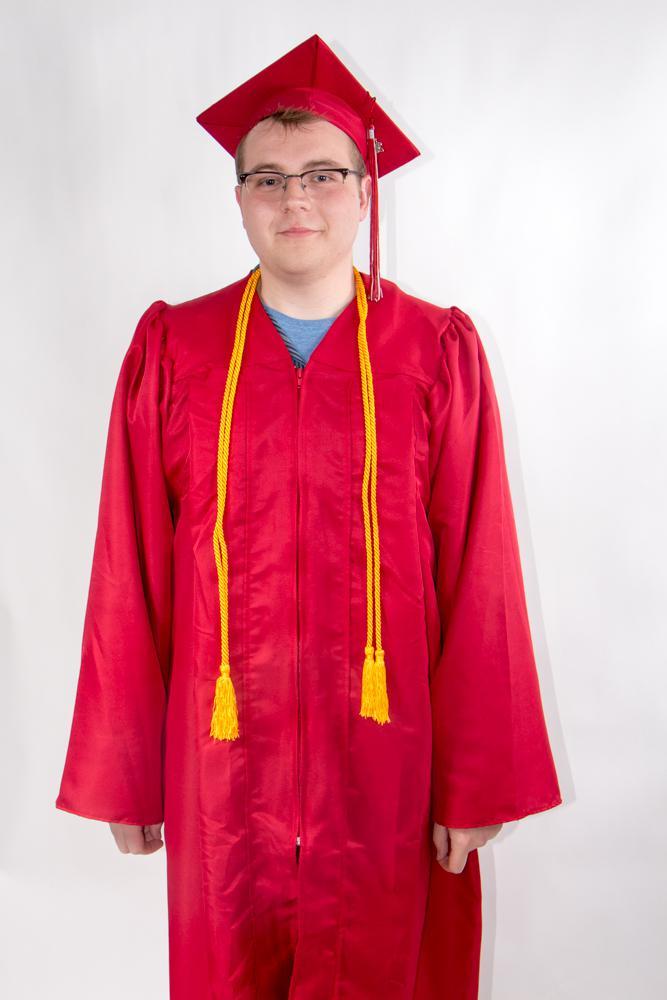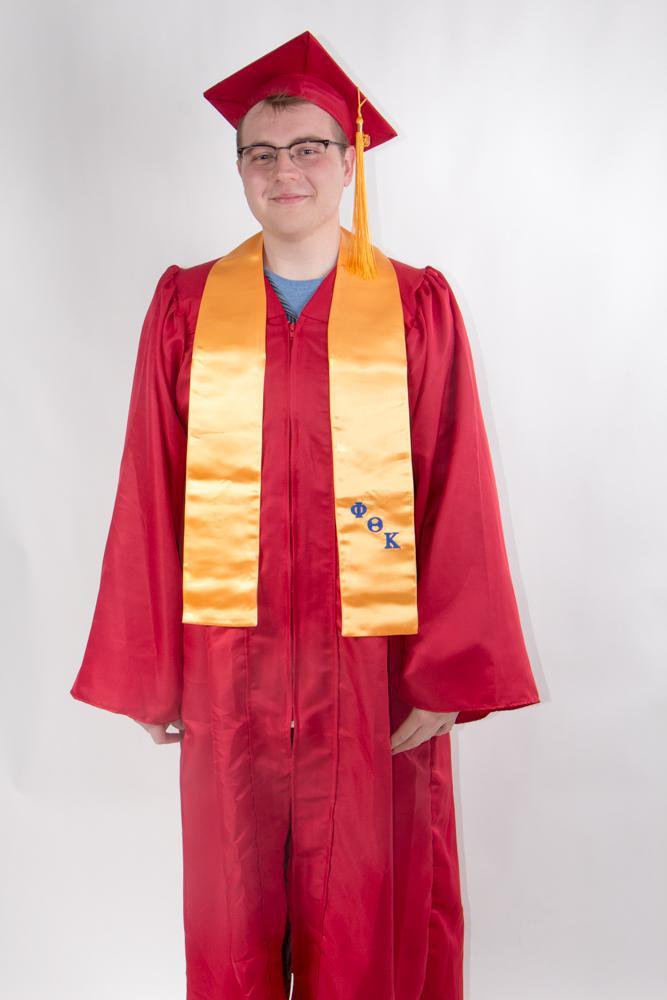The first image is the image on the left, the second image is the image on the right. Considering the images on both sides, is "The image on the left shows a student in graduation attire holding a diploma in their hands." valid? Answer yes or no. No. The first image is the image on the left, the second image is the image on the right. Analyze the images presented: Is the assertion "There are two images of people wearing graduation caps that have tassels hanging to the right." valid? Answer yes or no. Yes. 